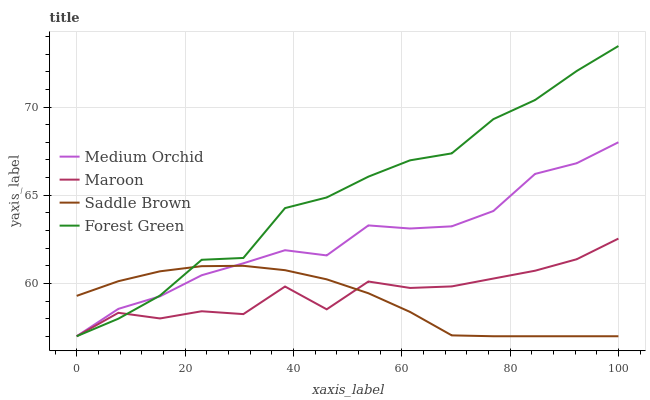Does Saddle Brown have the minimum area under the curve?
Answer yes or no. Yes. Does Forest Green have the maximum area under the curve?
Answer yes or no. Yes. Does Medium Orchid have the minimum area under the curve?
Answer yes or no. No. Does Medium Orchid have the maximum area under the curve?
Answer yes or no. No. Is Saddle Brown the smoothest?
Answer yes or no. Yes. Is Maroon the roughest?
Answer yes or no. Yes. Is Medium Orchid the smoothest?
Answer yes or no. No. Is Medium Orchid the roughest?
Answer yes or no. No. Does Forest Green have the lowest value?
Answer yes or no. Yes. Does Forest Green have the highest value?
Answer yes or no. Yes. Does Medium Orchid have the highest value?
Answer yes or no. No. Does Medium Orchid intersect Maroon?
Answer yes or no. Yes. Is Medium Orchid less than Maroon?
Answer yes or no. No. Is Medium Orchid greater than Maroon?
Answer yes or no. No. 